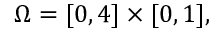<formula> <loc_0><loc_0><loc_500><loc_500>\Omega = [ 0 , 4 ] \times [ 0 , 1 ] ,</formula> 